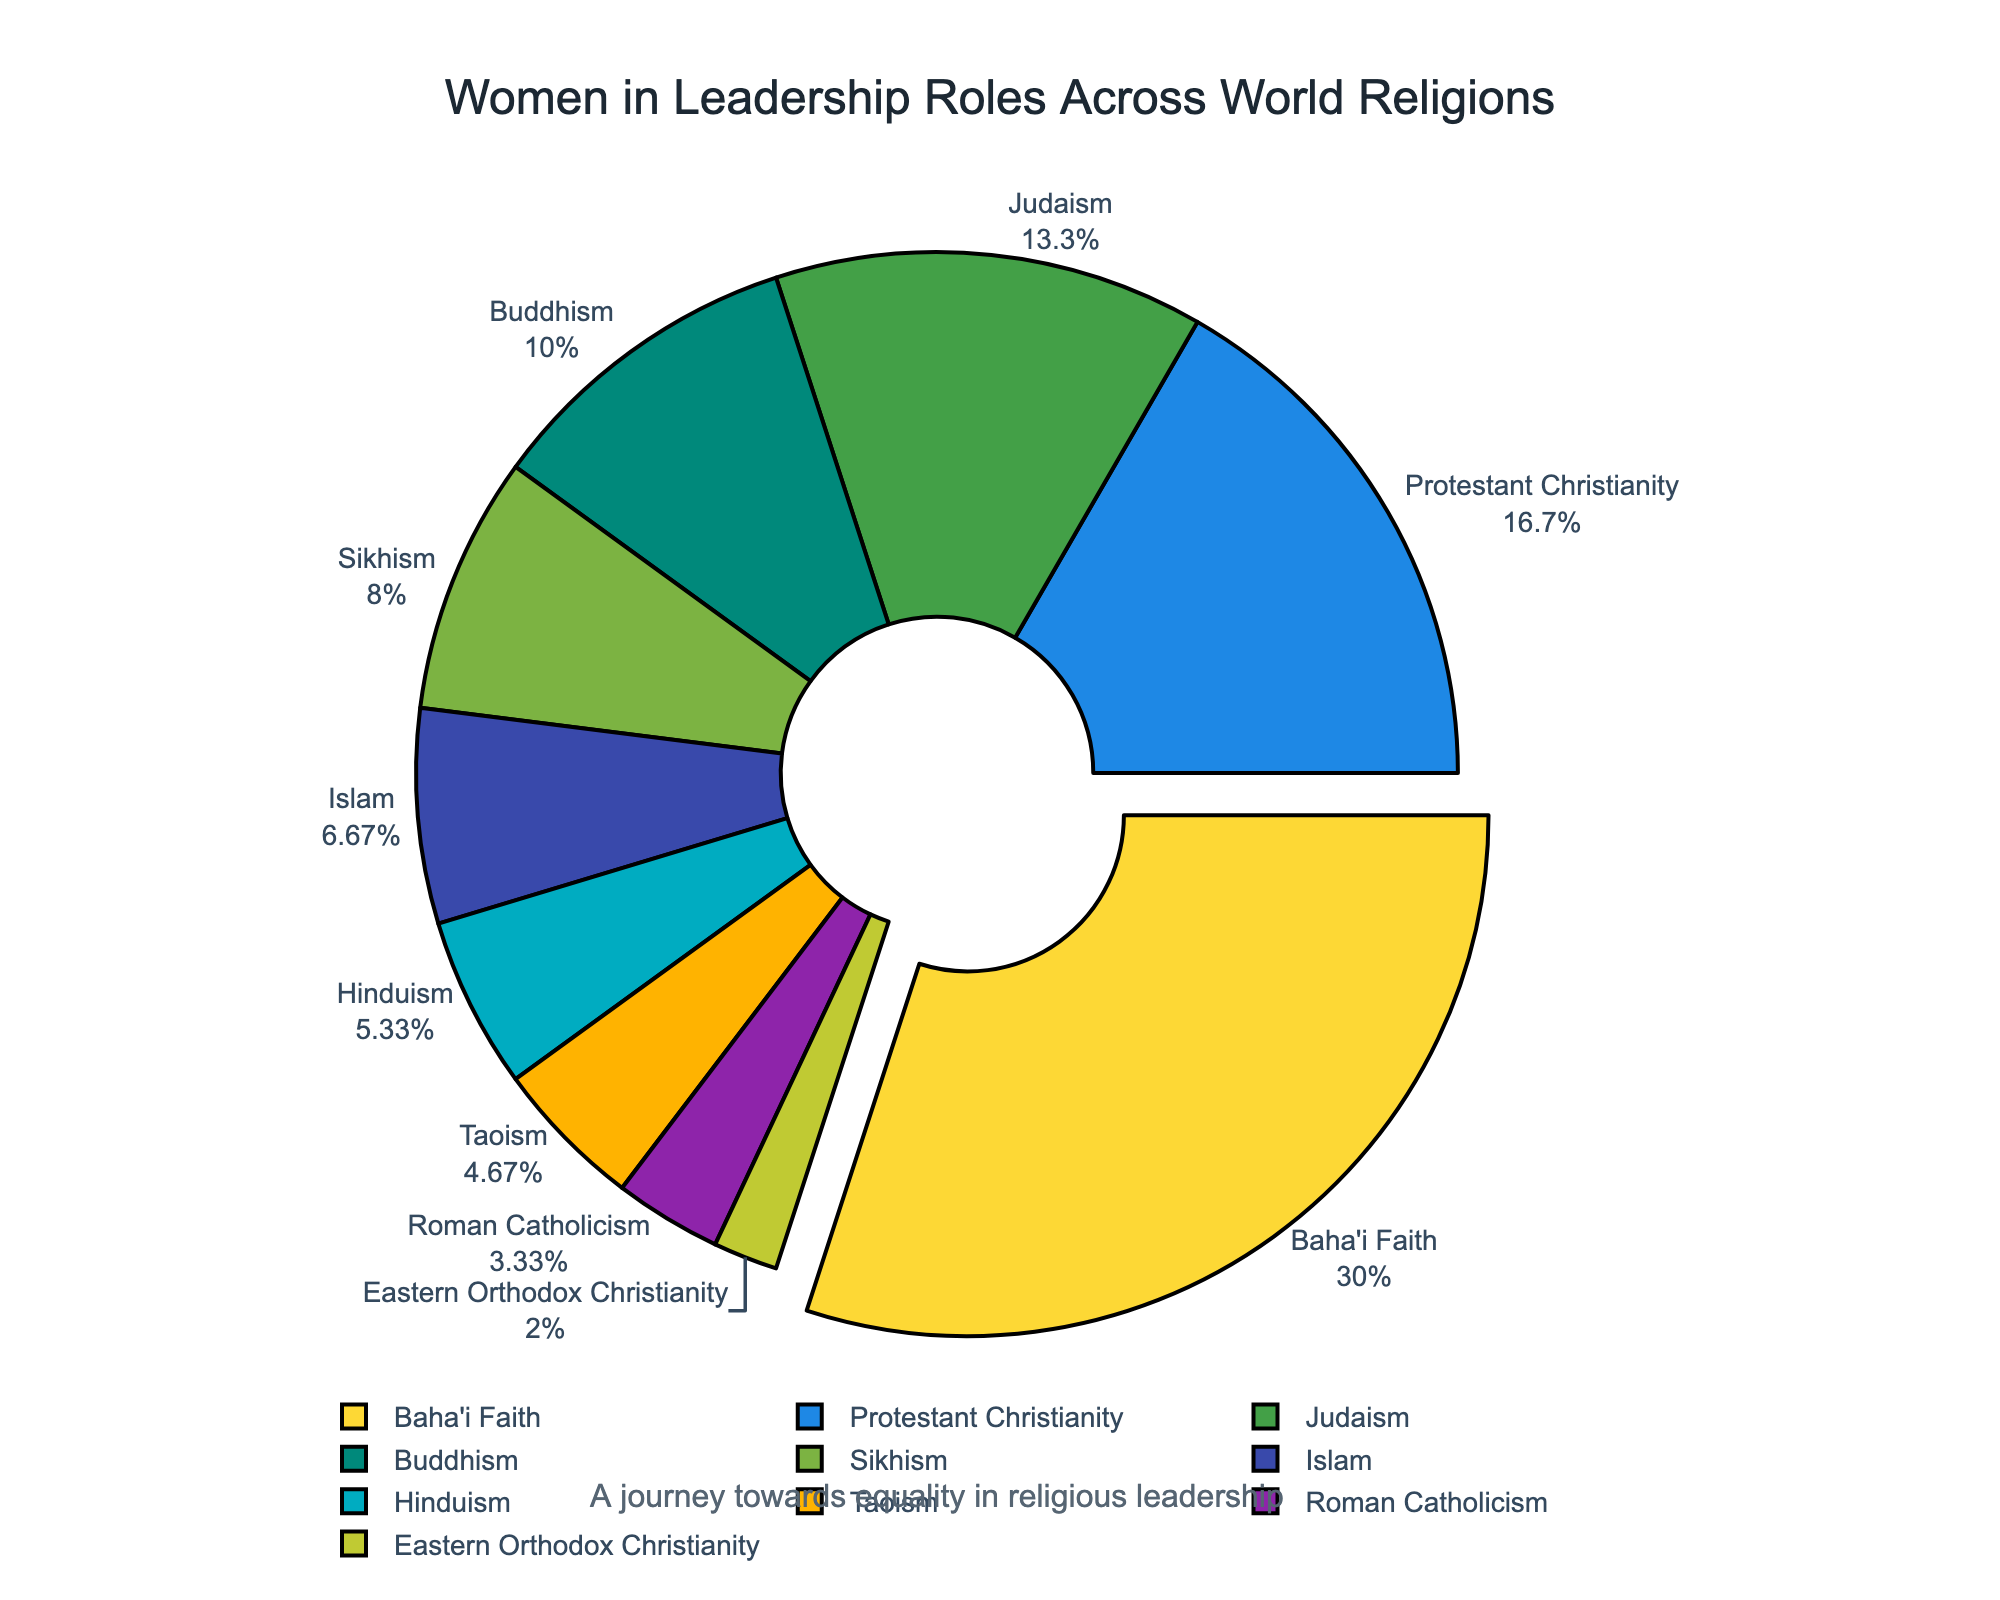What is the percentage of women in leadership roles in the Baha'i Faith? We observe the slice corresponding to the Baha'i Faith and see that it is the largest segment, with a percentage label.
Answer: 45 Which religion has the lowest percentage of women in leadership roles? By examining all segments, the smallest slice is related to Eastern Orthodox Christianity.
Answer: Eastern Orthodox Christianity How does the percentage of women in leadership roles in Protestant Christianity compare to Roman Catholicism? Protestant Christianity has a segment labeled with 25%, whereas Roman Catholicism's segment is labeled with 5%. Therefore, Protestant Christianity has a higher percentage.
Answer: Protestant Christianity has a higher percentage What is the combined percentage of women in leadership roles in Judaism and Buddhism? We look at the segments for Judaism and Buddhism, which respectively show 20% and 15%. Add these two percentages: 20% + 15% = 35%.
Answer: 35 Which religions have more than 10% of women in leadership roles? Inspect segments with percentages greater than 10%. These are Islam (10%), Protestant Christianity (25%), Buddhism (15%), Judaism (20%), Sikhism (12%), and Baha'i Faith (45%).
Answer: Islam, Protestant Christianity, Buddhism, Judaism, Sikhism, Baha'i Faith By how much does the percentage of women in leadership roles in Sikhism exceed Taoism? The percentage for Sikhism is 12% and for Taoism is 7%. The difference between these two is 12% - 7% = 5%.
Answer: 5% What is the average percentage of women in leadership roles across all shown religions? Sum all percentages and divide by the number of religions: (5 + 10 + 25 + 8 + 15 + 20 + 12 + 3 + 45 + 7) / 10 = 150 / 10 = 15%.
Answer: 15 Which religion has a 20% representation of women in leadership roles, and what is the segment color for it? The label for the 20% segment corresponds to Judaism. The segment has a distinct color among others, which is identified in the colors list as likely green.
Answer: Judaism, green How many religions have a percentage of women in leadership roles that is less than or equal to 10%? Check segments labeled 10% or less: Roman Catholicism (5%), Islam (10%), Hinduism (8%), Eastern Orthodox Christianity (3%), and Taoism (7%). Count these: 5.
Answer: 5 What is the difference in the percentage of women in leadership roles between Hinduism and Buddhism? Hinduism is labeled with 8% and Buddhism with 15%. The difference is 15% - 8% = 7%.
Answer: 7 